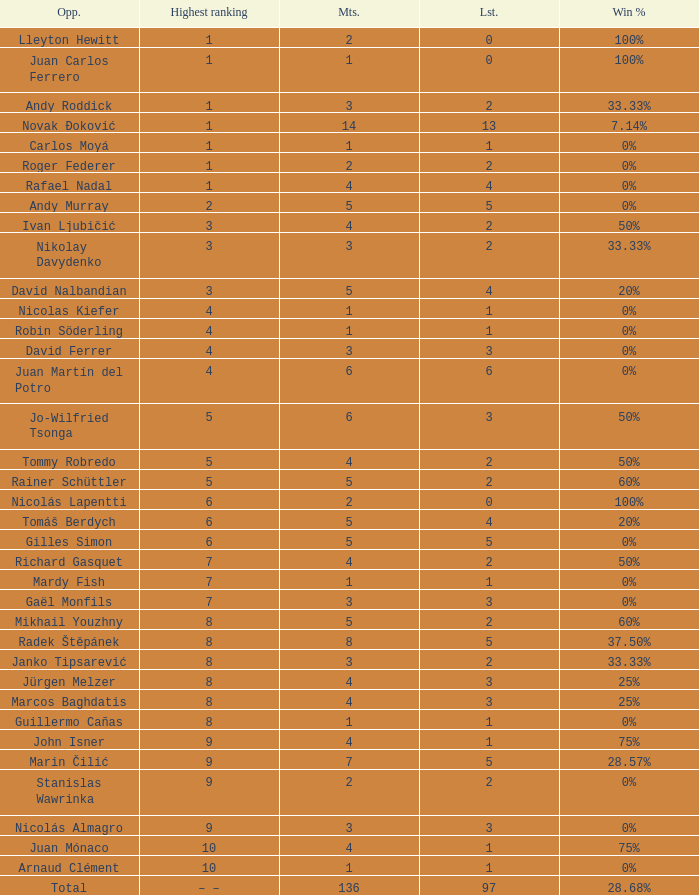What is the smallest number of Matches with less than 97 losses and a Win rate of 28.68%? None. 